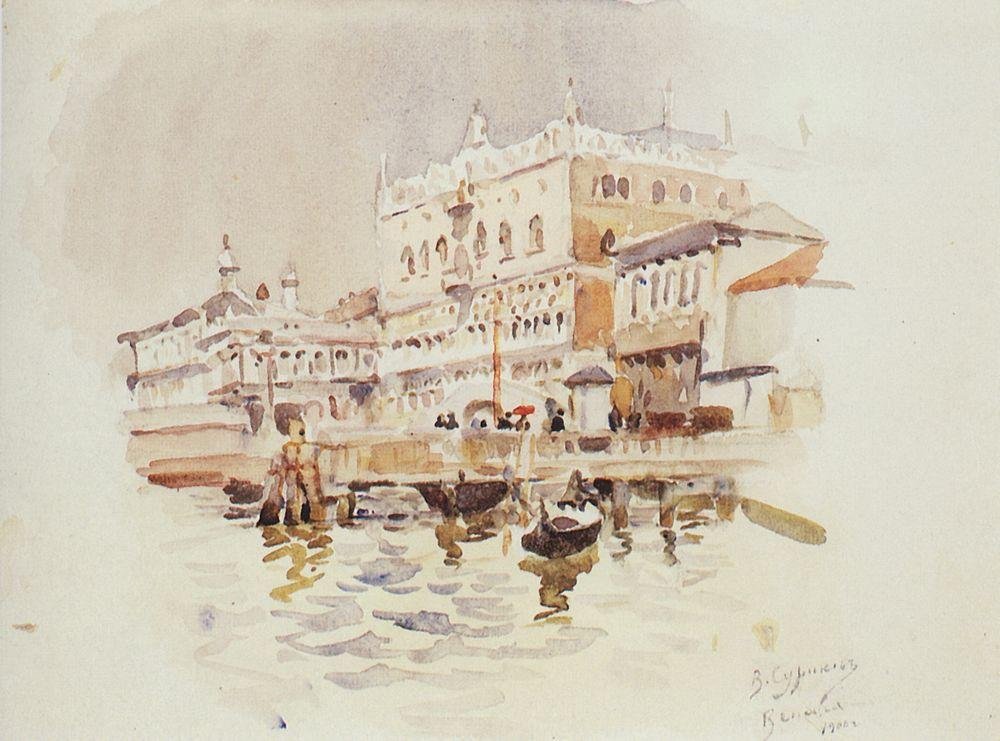What if the buildings could speak? What stories might they tell? If the buildings could speak, they would share tales of centuries of history. The grand palace, once the home of a powerful Venetian family, would recount lavish parties and political intrigues. It would speak of the city's golden age of trade and commerce, the art and culture that thrived within its walls, and the renowned guests it entertained. The smaller buildings around it, once bustling marketplaces and artisan workshops, would share stories of daily life, of craftspeople creating masterpieces, and of merchants negotiating deals that connected Venice to the far corners of the world. They would whisper secrets of romances, rivalries, and the everyday joys and sorrows of Venetians throughout the ages. Describe a day in the life of a 15th-century Venetian merchant navigating the Grand Canal. A 15th-century Venetian merchant starts his day before dawn, preparing his goods for the market. As the sun rises, he loads his boat with spices, silks, and other valuable items acquired from distant lands. Navigating the Grand Canal, he skilfully maneuvers through the bustling traffic of boats. The canal is a vibrant tapestry of activity, with water taxis, gondolas, and merchant vessels all vying for space. On reaching the Rialto Market, he sets up his stall, engaging in animated haggling with both locals and foreign traders. Throughout the day, he might strike lucrative deals, securing alliances, and new trade routes. By evening, he returns to his home, a grand palazzo, where his family waits. They share a meal, discussing the day's events and planning future ventures. As night falls, the merchant dreams of new opportunities, awaiting the arrival of the next ship that might bring exotic goods and stories from afar. 